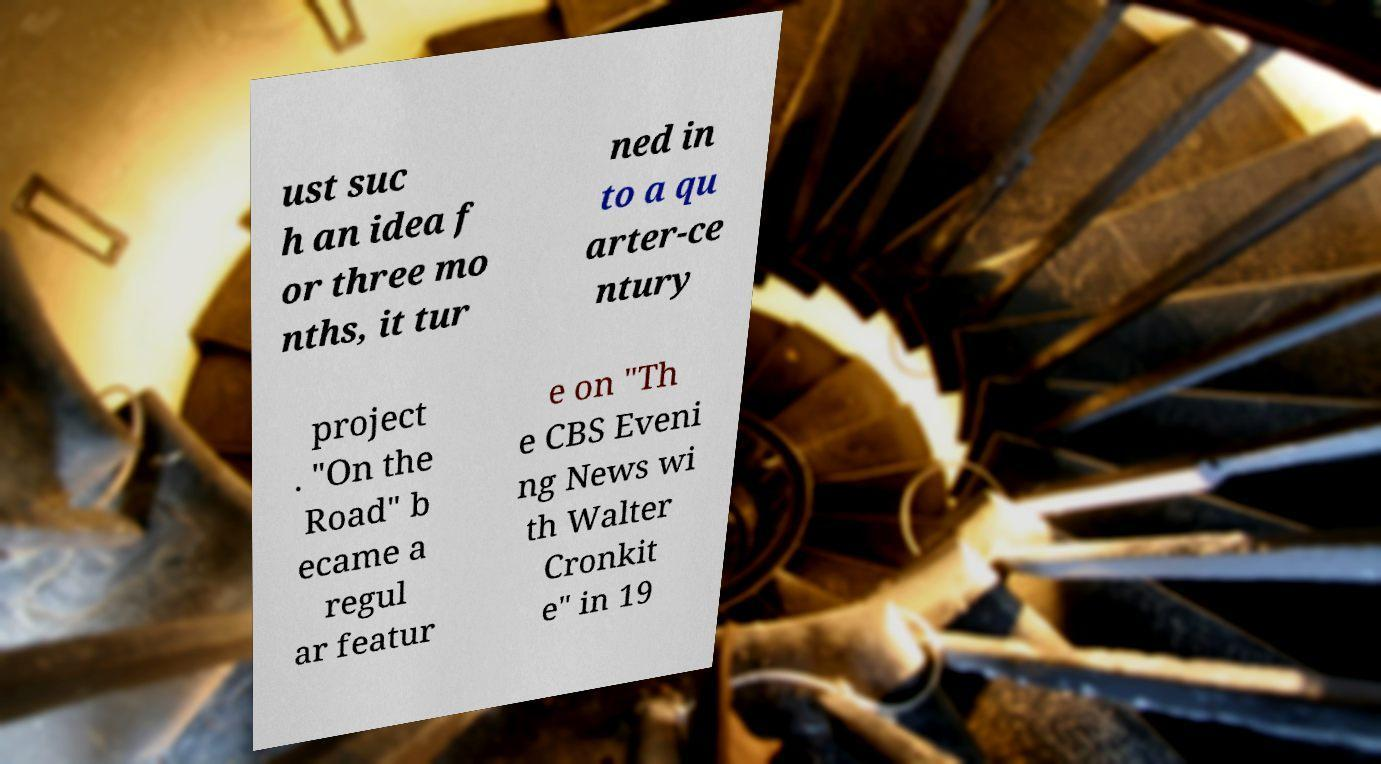Can you accurately transcribe the text from the provided image for me? ust suc h an idea f or three mo nths, it tur ned in to a qu arter-ce ntury project . "On the Road" b ecame a regul ar featur e on "Th e CBS Eveni ng News wi th Walter Cronkit e" in 19 